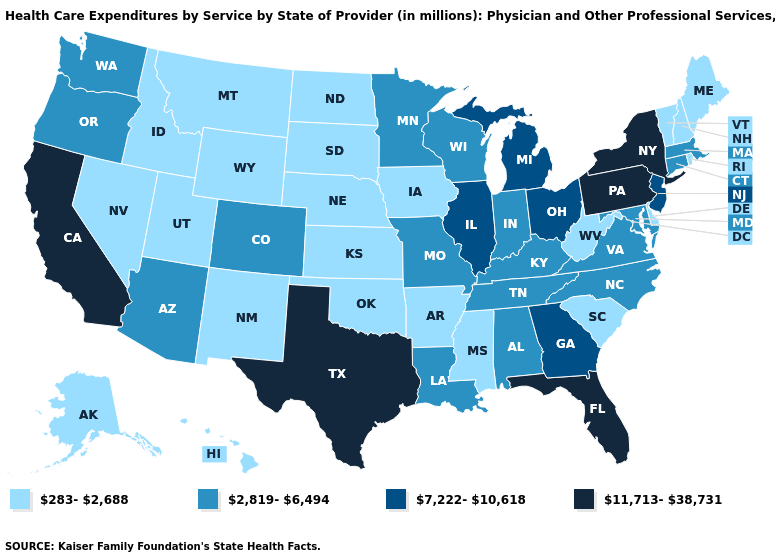Name the states that have a value in the range 2,819-6,494?
Give a very brief answer. Alabama, Arizona, Colorado, Connecticut, Indiana, Kentucky, Louisiana, Maryland, Massachusetts, Minnesota, Missouri, North Carolina, Oregon, Tennessee, Virginia, Washington, Wisconsin. Name the states that have a value in the range 283-2,688?
Concise answer only. Alaska, Arkansas, Delaware, Hawaii, Idaho, Iowa, Kansas, Maine, Mississippi, Montana, Nebraska, Nevada, New Hampshire, New Mexico, North Dakota, Oklahoma, Rhode Island, South Carolina, South Dakota, Utah, Vermont, West Virginia, Wyoming. What is the value of Nevada?
Write a very short answer. 283-2,688. What is the value of Kentucky?
Give a very brief answer. 2,819-6,494. Does Oklahoma have the lowest value in the South?
Be succinct. Yes. Name the states that have a value in the range 2,819-6,494?
Answer briefly. Alabama, Arizona, Colorado, Connecticut, Indiana, Kentucky, Louisiana, Maryland, Massachusetts, Minnesota, Missouri, North Carolina, Oregon, Tennessee, Virginia, Washington, Wisconsin. Among the states that border Nevada , which have the lowest value?
Write a very short answer. Idaho, Utah. Does New York have the highest value in the Northeast?
Be succinct. Yes. How many symbols are there in the legend?
Be succinct. 4. What is the lowest value in states that border Georgia?
Concise answer only. 283-2,688. What is the value of New York?
Give a very brief answer. 11,713-38,731. What is the value of Nevada?
Quick response, please. 283-2,688. Among the states that border Alabama , does Florida have the highest value?
Write a very short answer. Yes. Which states have the lowest value in the USA?
Answer briefly. Alaska, Arkansas, Delaware, Hawaii, Idaho, Iowa, Kansas, Maine, Mississippi, Montana, Nebraska, Nevada, New Hampshire, New Mexico, North Dakota, Oklahoma, Rhode Island, South Carolina, South Dakota, Utah, Vermont, West Virginia, Wyoming. What is the lowest value in states that border Tennessee?
Write a very short answer. 283-2,688. 